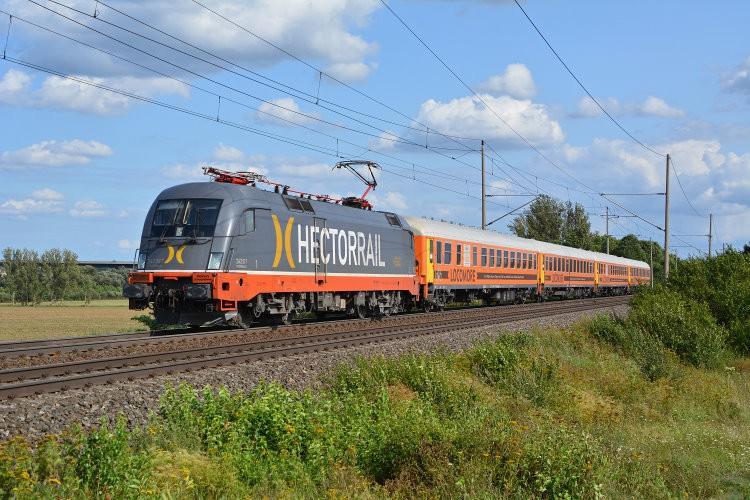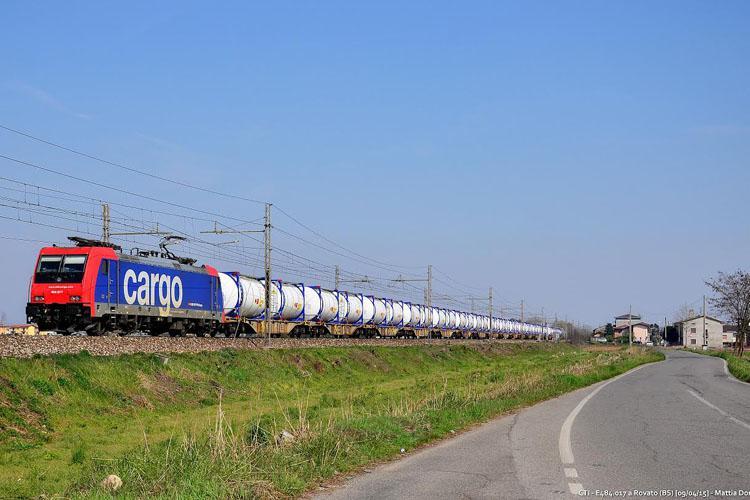The first image is the image on the left, the second image is the image on the right. Given the left and right images, does the statement "In the right image, the train doesn't appear to be hauling anything." hold true? Answer yes or no. No. The first image is the image on the left, the second image is the image on the right. Considering the images on both sides, is "on the right side a single care is heading to the left" valid? Answer yes or no. No. 